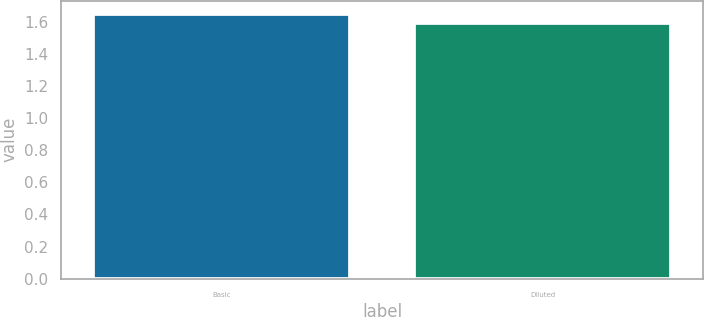Convert chart to OTSL. <chart><loc_0><loc_0><loc_500><loc_500><bar_chart><fcel>Basic<fcel>Diluted<nl><fcel>1.65<fcel>1.59<nl></chart> 